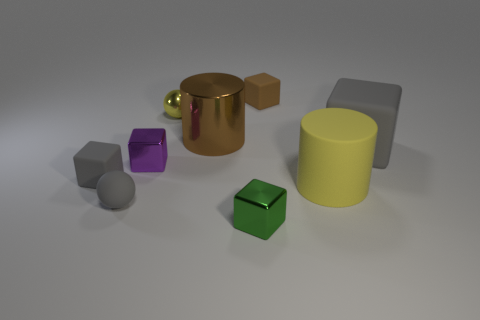Subtract 2 blocks. How many blocks are left? 3 Subtract all tiny brown matte cubes. How many cubes are left? 4 Subtract all green blocks. How many blocks are left? 4 Subtract all blue blocks. Subtract all red cylinders. How many blocks are left? 5 Add 1 small red metal cubes. How many objects exist? 10 Subtract all cylinders. How many objects are left? 7 Subtract all tiny brown rubber cubes. Subtract all small metallic balls. How many objects are left? 7 Add 7 big yellow rubber things. How many big yellow rubber things are left? 8 Add 9 yellow metallic balls. How many yellow metallic balls exist? 10 Subtract 2 gray cubes. How many objects are left? 7 